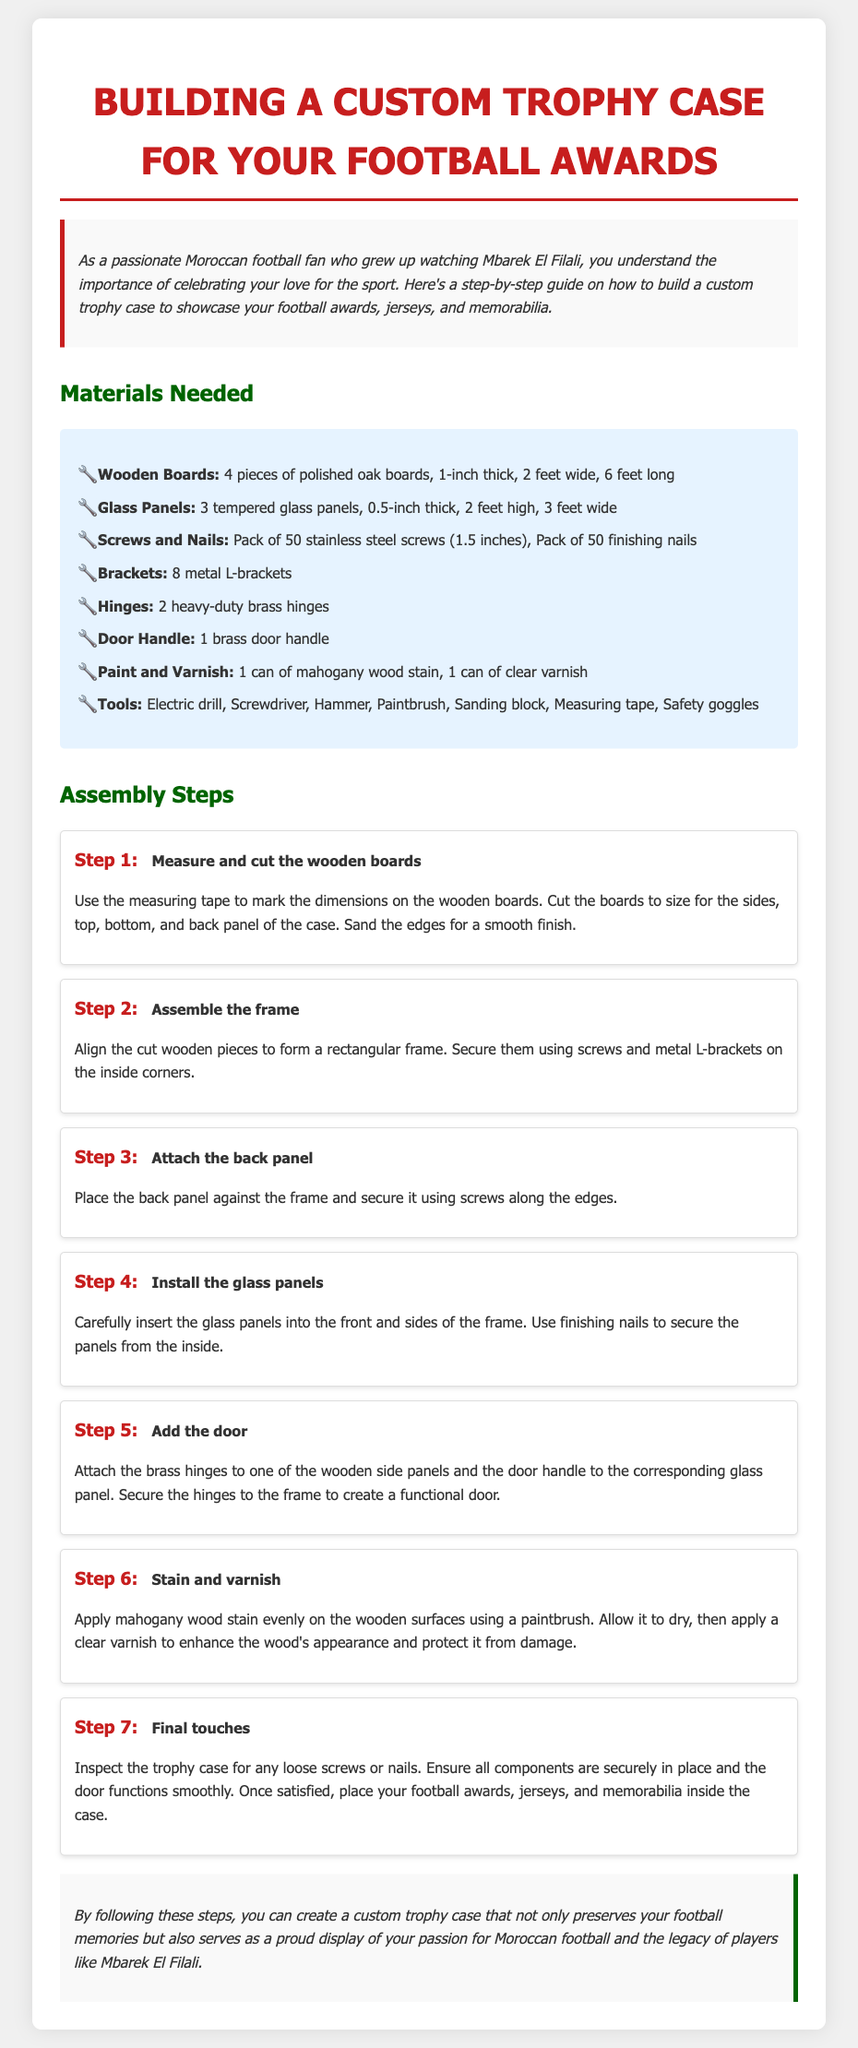What is the title of the document? The title is the main heading of the document, which is provided in the opening section.
Answer: Building a Custom Trophy Case for Your Football Awards How many wooden boards are needed? The number of wooden boards is listed under the materials needed section.
Answer: 4 pieces What thickness are the glass panels? The thickness of the glass panels is specified in the materials section, detailing their dimensions.
Answer: 0.5-inch What is the first step in the assembly process? The first step outlines the initial action required to begin the project, as found in the assembly steps section.
Answer: Measure and cut the wooden boards Which type of wood stain is mentioned? The specific type of wood stain is indicated in the materials needed section for finishing the trophy case.
Answer: mahogany How many metal L-brackets are required? The quantity of metal L-brackets is provided in the materials section, alongside the other components.
Answer: 8 What should you inspect during the final touches? The final touches include actions to ensure quality and function, as explained in the last assembly step.
Answer: loose screws or nails What tools are necessary for this project? The tools needed for assembly are listed in the materials section, showing the equipment needed.
Answer: Electric drill, Screwdriver, Hammer, Paintbrush, Sanding block, Measuring tape, Safety goggles What is used to secure the glass panels? The method for securing the glass panels is described in one of the assembly steps.
Answer: finishing nails 